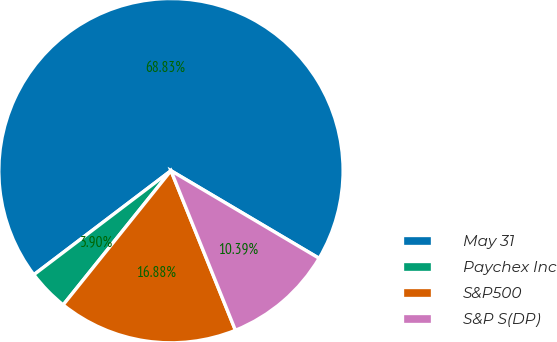<chart> <loc_0><loc_0><loc_500><loc_500><pie_chart><fcel>May 31<fcel>Paychex Inc<fcel>S&P500<fcel>S&P S(DP)<nl><fcel>68.83%<fcel>3.9%<fcel>16.88%<fcel>10.39%<nl></chart> 